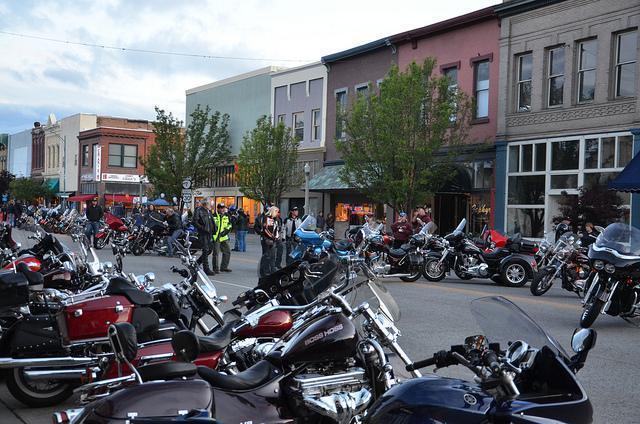How many motorcycles are in the picture?
Give a very brief answer. 9. How many layers does this cake have?
Give a very brief answer. 0. 